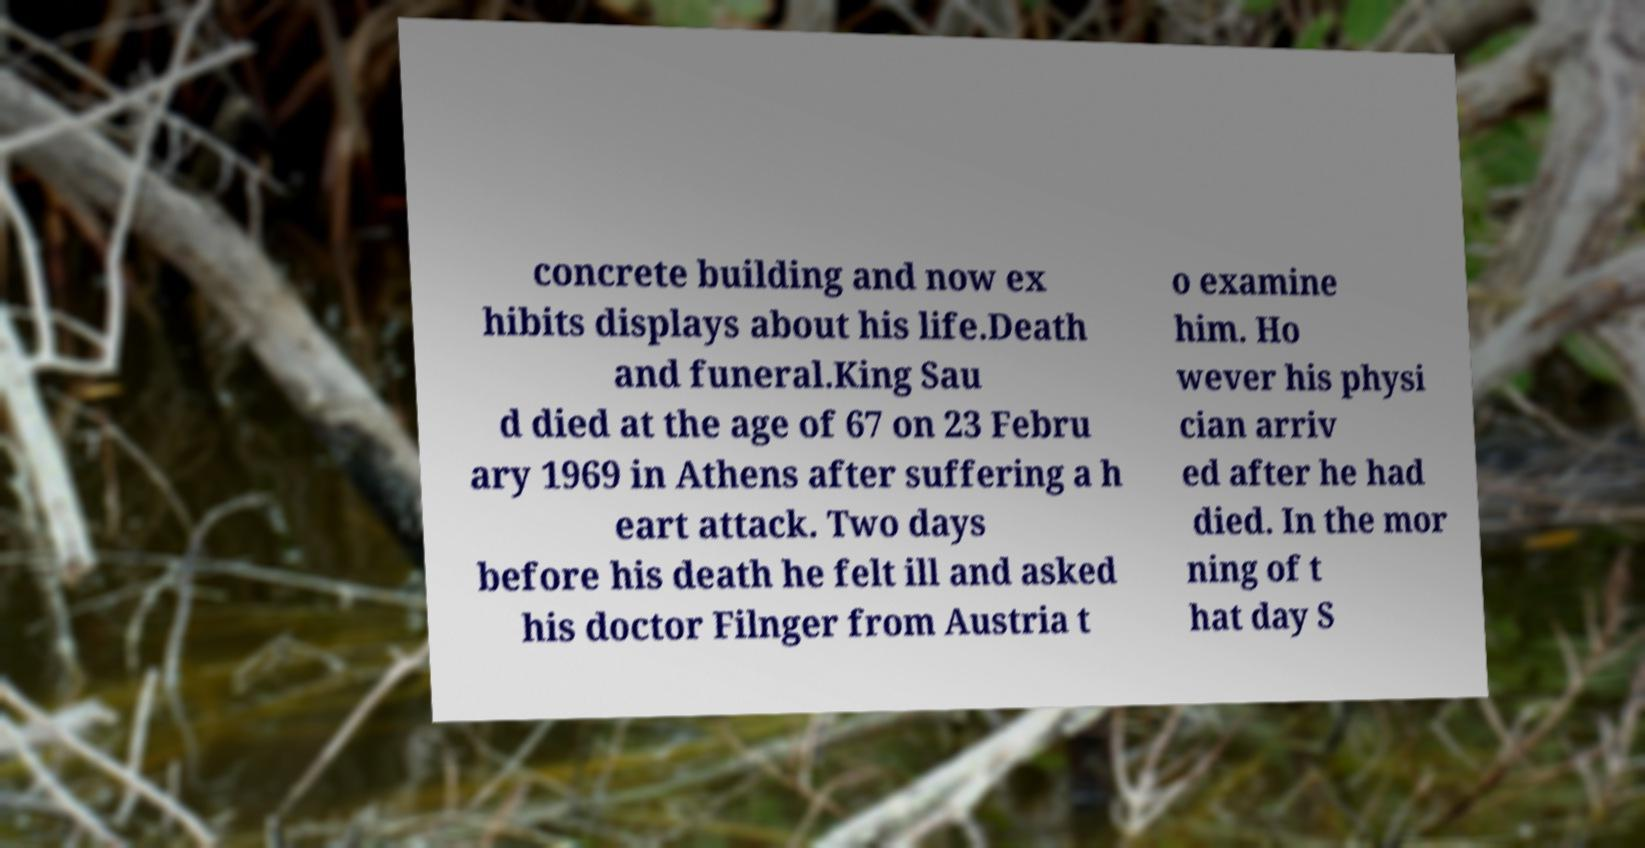Could you extract and type out the text from this image? concrete building and now ex hibits displays about his life.Death and funeral.King Sau d died at the age of 67 on 23 Febru ary 1969 in Athens after suffering a h eart attack. Two days before his death he felt ill and asked his doctor Filnger from Austria t o examine him. Ho wever his physi cian arriv ed after he had died. In the mor ning of t hat day S 